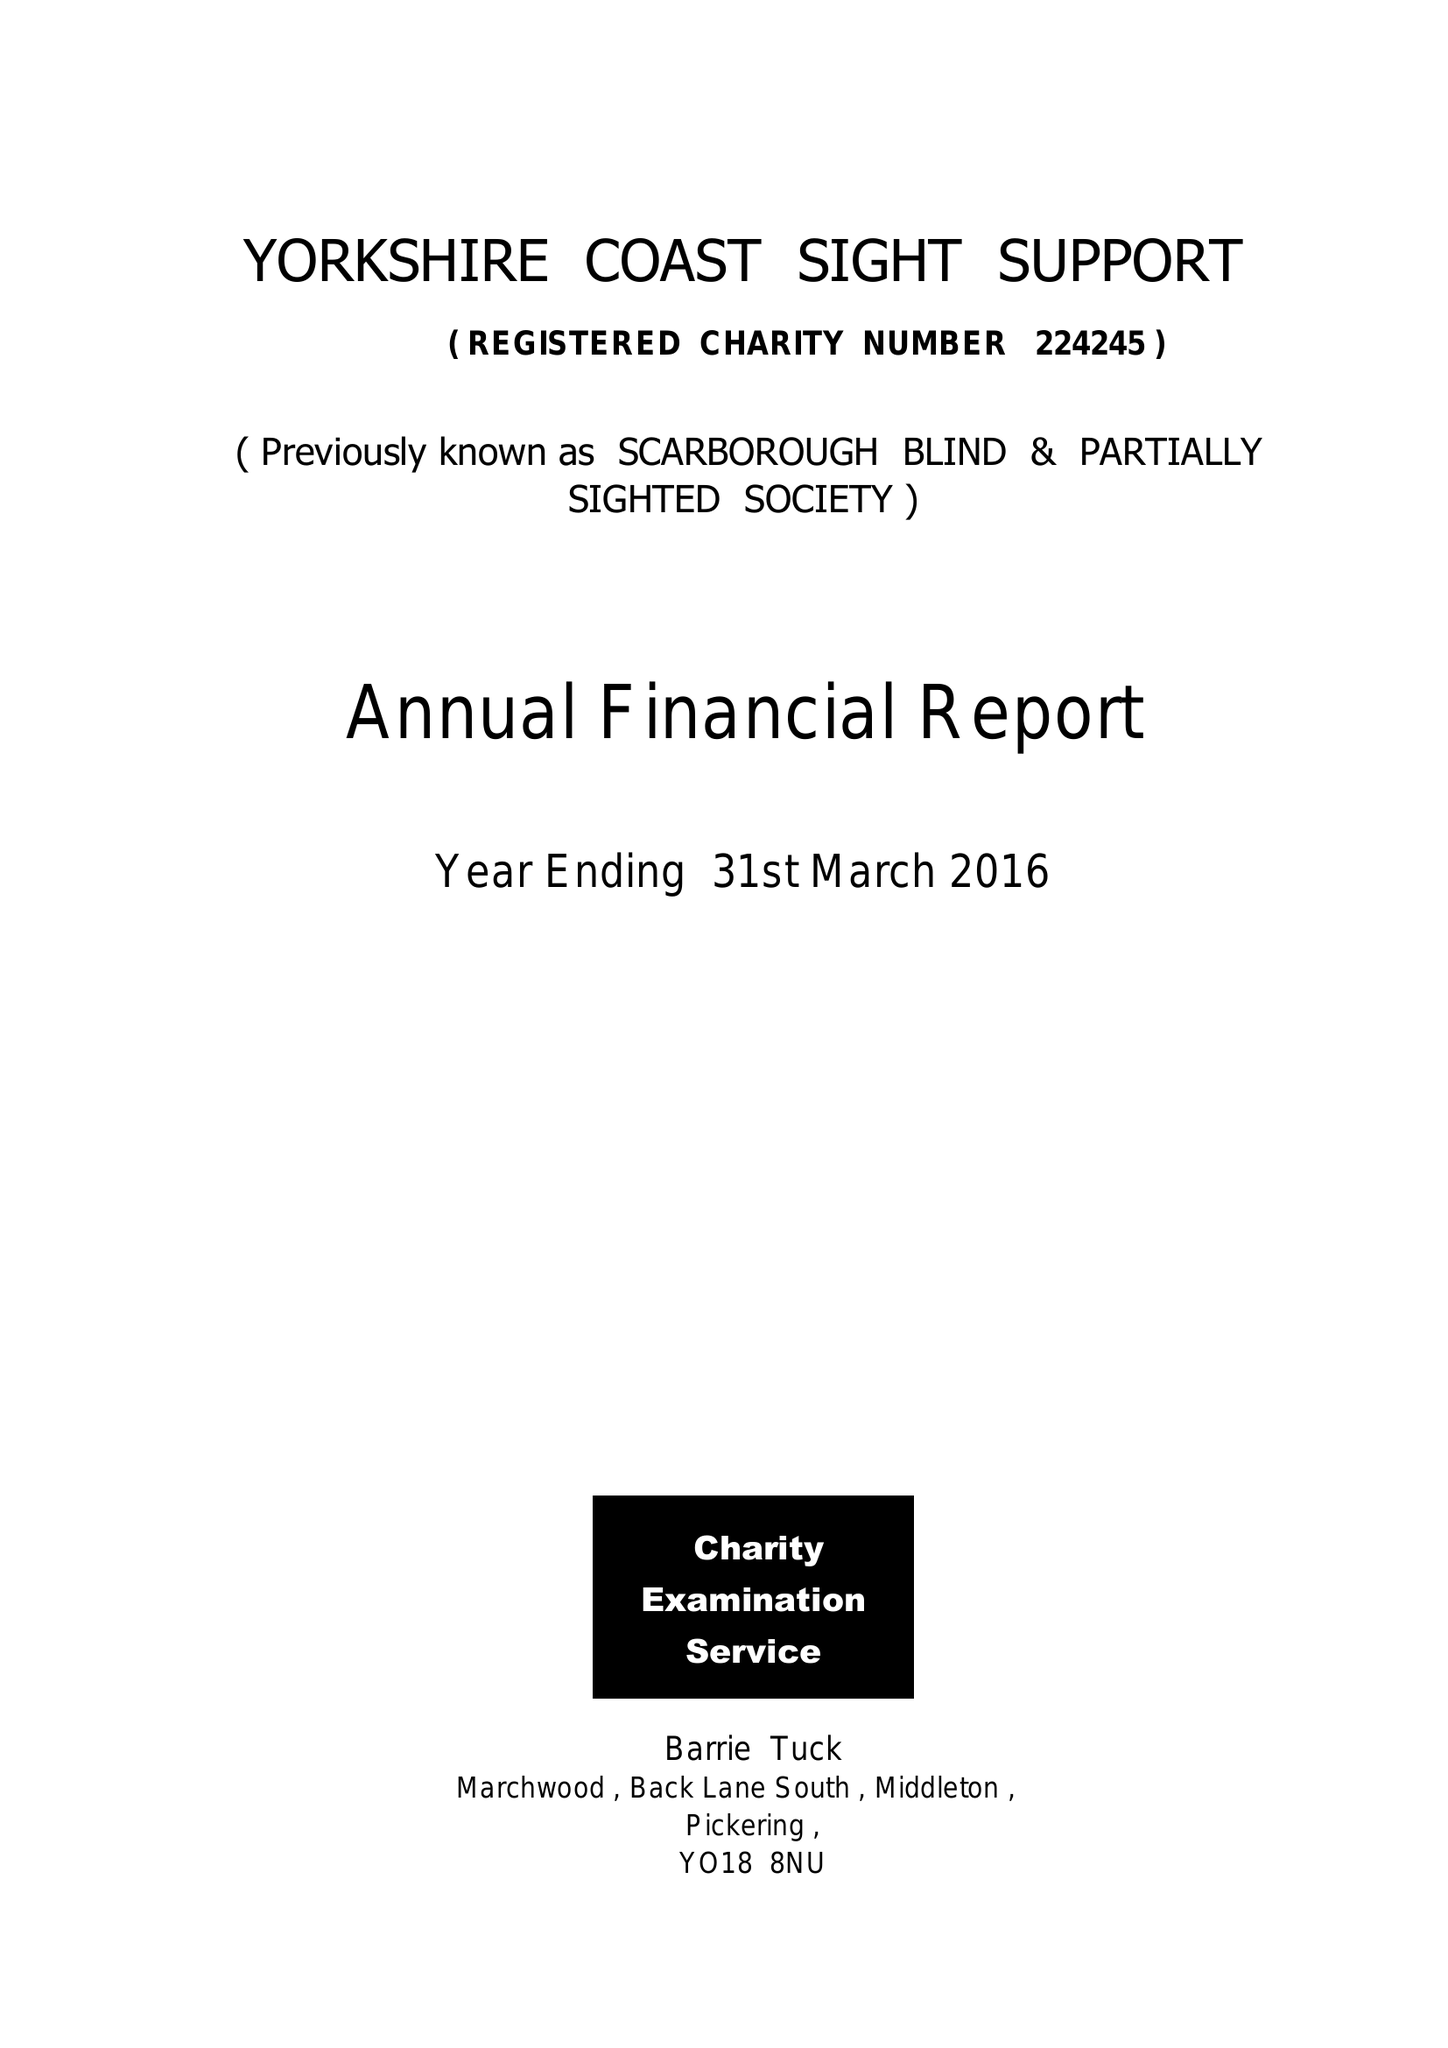What is the value for the income_annually_in_british_pounds?
Answer the question using a single word or phrase. 64701.00 